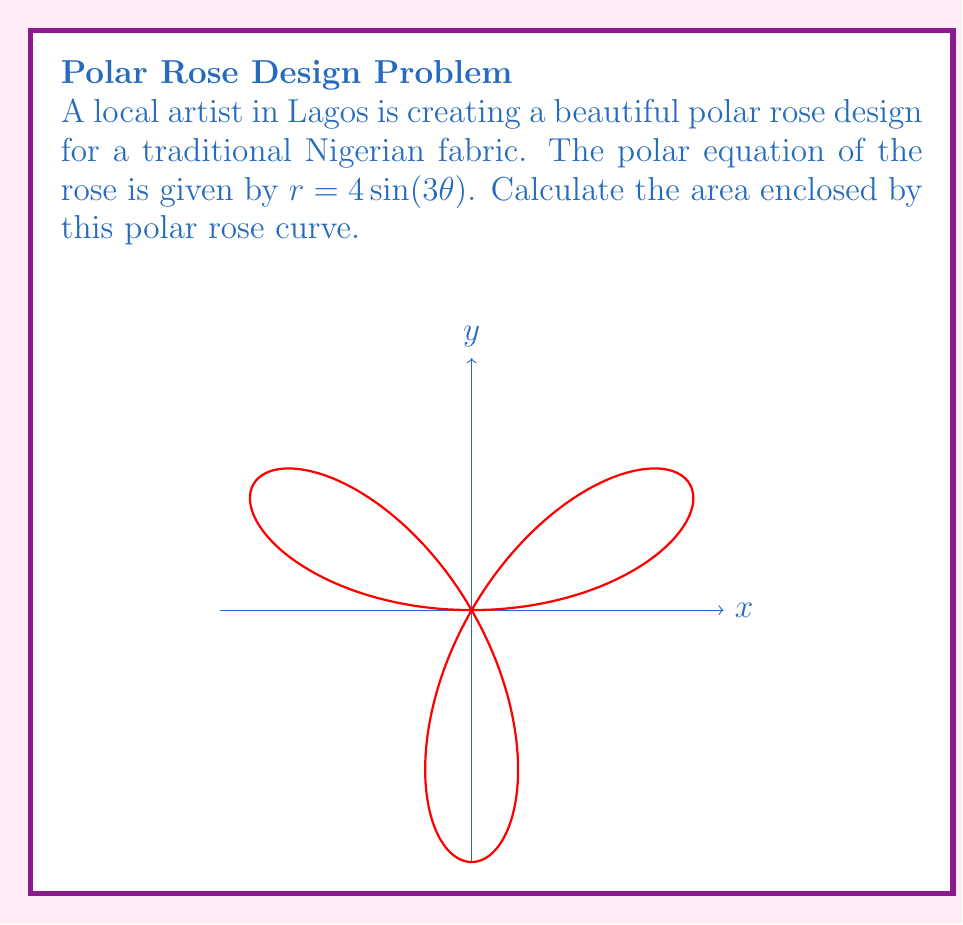Teach me how to tackle this problem. Let's approach this step-by-step:

1) The general formula for the area enclosed by a polar curve is:

   $$A = \frac{1}{2} \int_0^{2\pi} r^2(\theta) d\theta$$

2) In our case, $r = 4\sin(3\theta)$, so $r^2 = 16\sin^2(3\theta)$

3) Substituting this into our formula:

   $$A = \frac{1}{2} \int_0^{2\pi} 16\sin^2(3\theta) d\theta$$

4) We can simplify this using the trigonometric identity $\sin^2(x) = \frac{1 - \cos(2x)}{2}$:

   $$A = \frac{1}{2} \int_0^{2\pi} 16 \cdot \frac{1 - \cos(6\theta)}{2} d\theta$$

5) Simplifying:

   $$A = 4 \int_0^{2\pi} (1 - \cos(6\theta)) d\theta$$

6) Integrating:

   $$A = 4 [\theta - \frac{1}{6}\sin(6\theta)]_0^{2\pi}$$

7) Evaluating the limits:

   $$A = 4 [(2\pi - 0) - (\frac{1}{6}\sin(12\pi) - \frac{1}{6}\sin(0))]$$

8) Simplify:

   $$A = 4 [2\pi - 0] = 8\pi$$

Therefore, the area enclosed by the polar rose is $8\pi$ square units.
Answer: $8\pi$ square units 